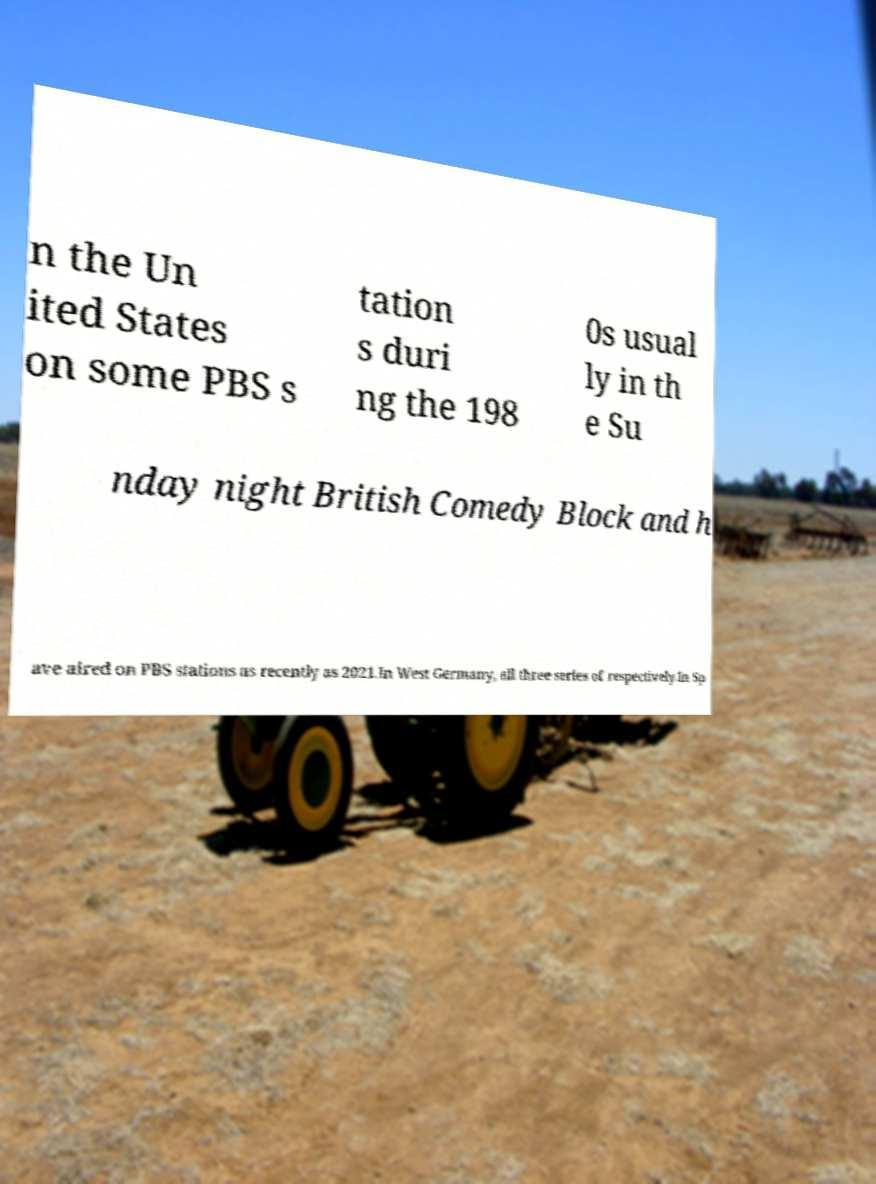Please read and relay the text visible in this image. What does it say? n the Un ited States on some PBS s tation s duri ng the 198 0s usual ly in th e Su nday night British Comedy Block and h ave aired on PBS stations as recently as 2021.In West Germany, all three series of respectively.In Sp 